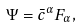<formula> <loc_0><loc_0><loc_500><loc_500>\Psi = \bar { c } ^ { \alpha } F _ { \alpha } ,</formula> 